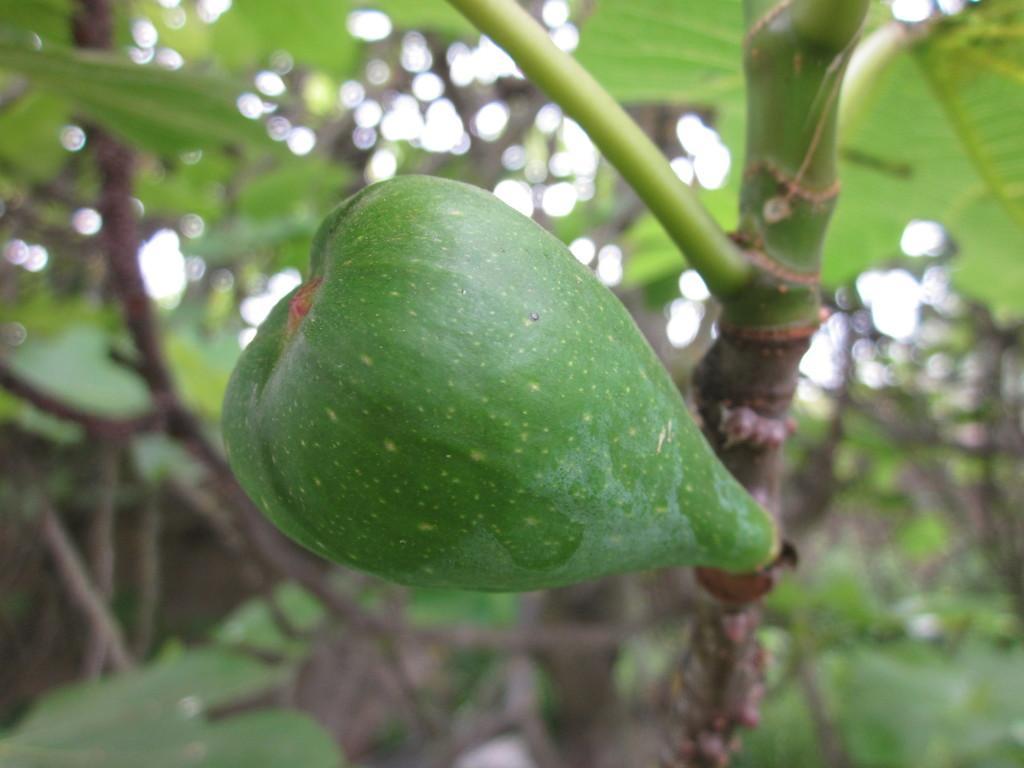In one or two sentences, can you explain what this image depicts? In this picture I can see a fruit to the branch of a tree, and in the background there are trees. 